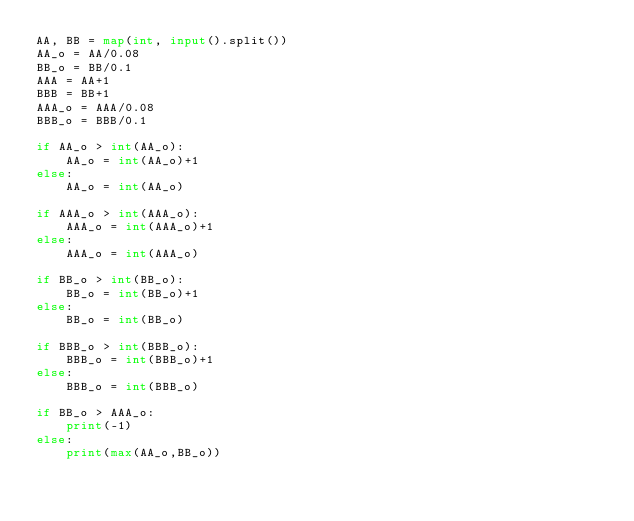Convert code to text. <code><loc_0><loc_0><loc_500><loc_500><_Python_>AA, BB = map(int, input().split())
AA_o = AA/0.08
BB_o = BB/0.1
AAA = AA+1
BBB = BB+1
AAA_o = AAA/0.08
BBB_o = BBB/0.1

if AA_o > int(AA_o):
    AA_o = int(AA_o)+1
else:
    AA_o = int(AA_o)

if AAA_o > int(AAA_o):
    AAA_o = int(AAA_o)+1
else:
    AAA_o = int(AAA_o)
    
if BB_o > int(BB_o):
    BB_o = int(BB_o)+1
else:
    BB_o = int(BB_o)

if BBB_o > int(BBB_o):
    BBB_o = int(BBB_o)+1
else:
    BBB_o = int(BBB_o)
    
if BB_o > AAA_o:
    print(-1)
else:
    print(max(AA_o,BB_o))</code> 